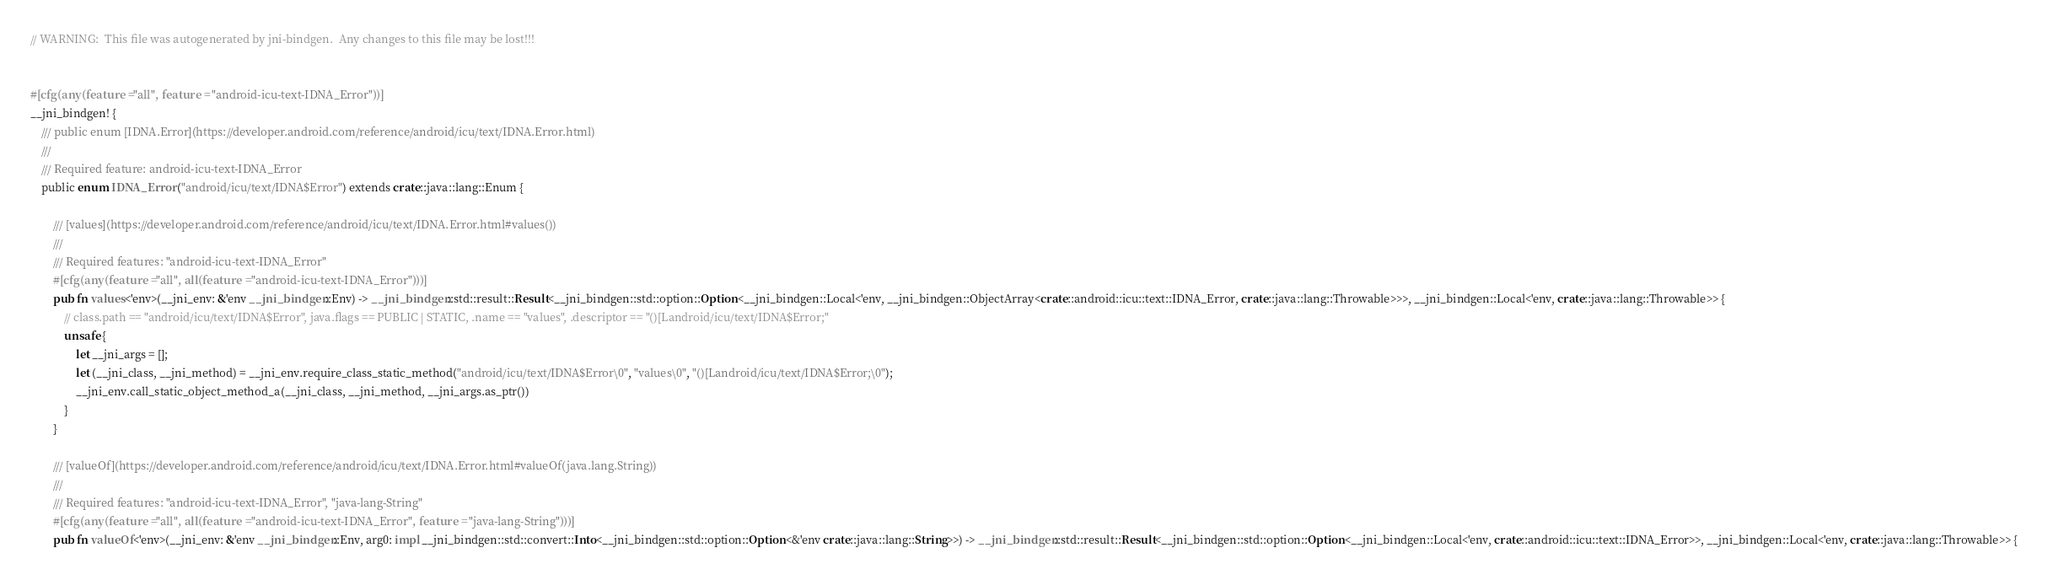Convert code to text. <code><loc_0><loc_0><loc_500><loc_500><_Rust_>// WARNING:  This file was autogenerated by jni-bindgen.  Any changes to this file may be lost!!!


#[cfg(any(feature = "all", feature = "android-icu-text-IDNA_Error"))]
__jni_bindgen! {
    /// public enum [IDNA.Error](https://developer.android.com/reference/android/icu/text/IDNA.Error.html)
    ///
    /// Required feature: android-icu-text-IDNA_Error
    public enum IDNA_Error ("android/icu/text/IDNA$Error") extends crate::java::lang::Enum {

        /// [values](https://developer.android.com/reference/android/icu/text/IDNA.Error.html#values())
        ///
        /// Required features: "android-icu-text-IDNA_Error"
        #[cfg(any(feature = "all", all(feature = "android-icu-text-IDNA_Error")))]
        pub fn values<'env>(__jni_env: &'env __jni_bindgen::Env) -> __jni_bindgen::std::result::Result<__jni_bindgen::std::option::Option<__jni_bindgen::Local<'env, __jni_bindgen::ObjectArray<crate::android::icu::text::IDNA_Error, crate::java::lang::Throwable>>>, __jni_bindgen::Local<'env, crate::java::lang::Throwable>> {
            // class.path == "android/icu/text/IDNA$Error", java.flags == PUBLIC | STATIC, .name == "values", .descriptor == "()[Landroid/icu/text/IDNA$Error;"
            unsafe {
                let __jni_args = [];
                let (__jni_class, __jni_method) = __jni_env.require_class_static_method("android/icu/text/IDNA$Error\0", "values\0", "()[Landroid/icu/text/IDNA$Error;\0");
                __jni_env.call_static_object_method_a(__jni_class, __jni_method, __jni_args.as_ptr())
            }
        }

        /// [valueOf](https://developer.android.com/reference/android/icu/text/IDNA.Error.html#valueOf(java.lang.String))
        ///
        /// Required features: "android-icu-text-IDNA_Error", "java-lang-String"
        #[cfg(any(feature = "all", all(feature = "android-icu-text-IDNA_Error", feature = "java-lang-String")))]
        pub fn valueOf<'env>(__jni_env: &'env __jni_bindgen::Env, arg0: impl __jni_bindgen::std::convert::Into<__jni_bindgen::std::option::Option<&'env crate::java::lang::String>>) -> __jni_bindgen::std::result::Result<__jni_bindgen::std::option::Option<__jni_bindgen::Local<'env, crate::android::icu::text::IDNA_Error>>, __jni_bindgen::Local<'env, crate::java::lang::Throwable>> {</code> 